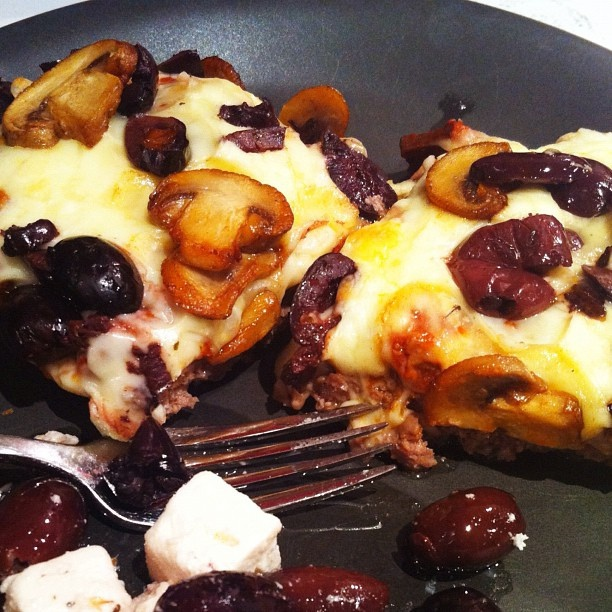Describe the objects in this image and their specific colors. I can see pizza in lightgray, maroon, khaki, lightyellow, and black tones and fork in lightgray, black, maroon, white, and brown tones in this image. 